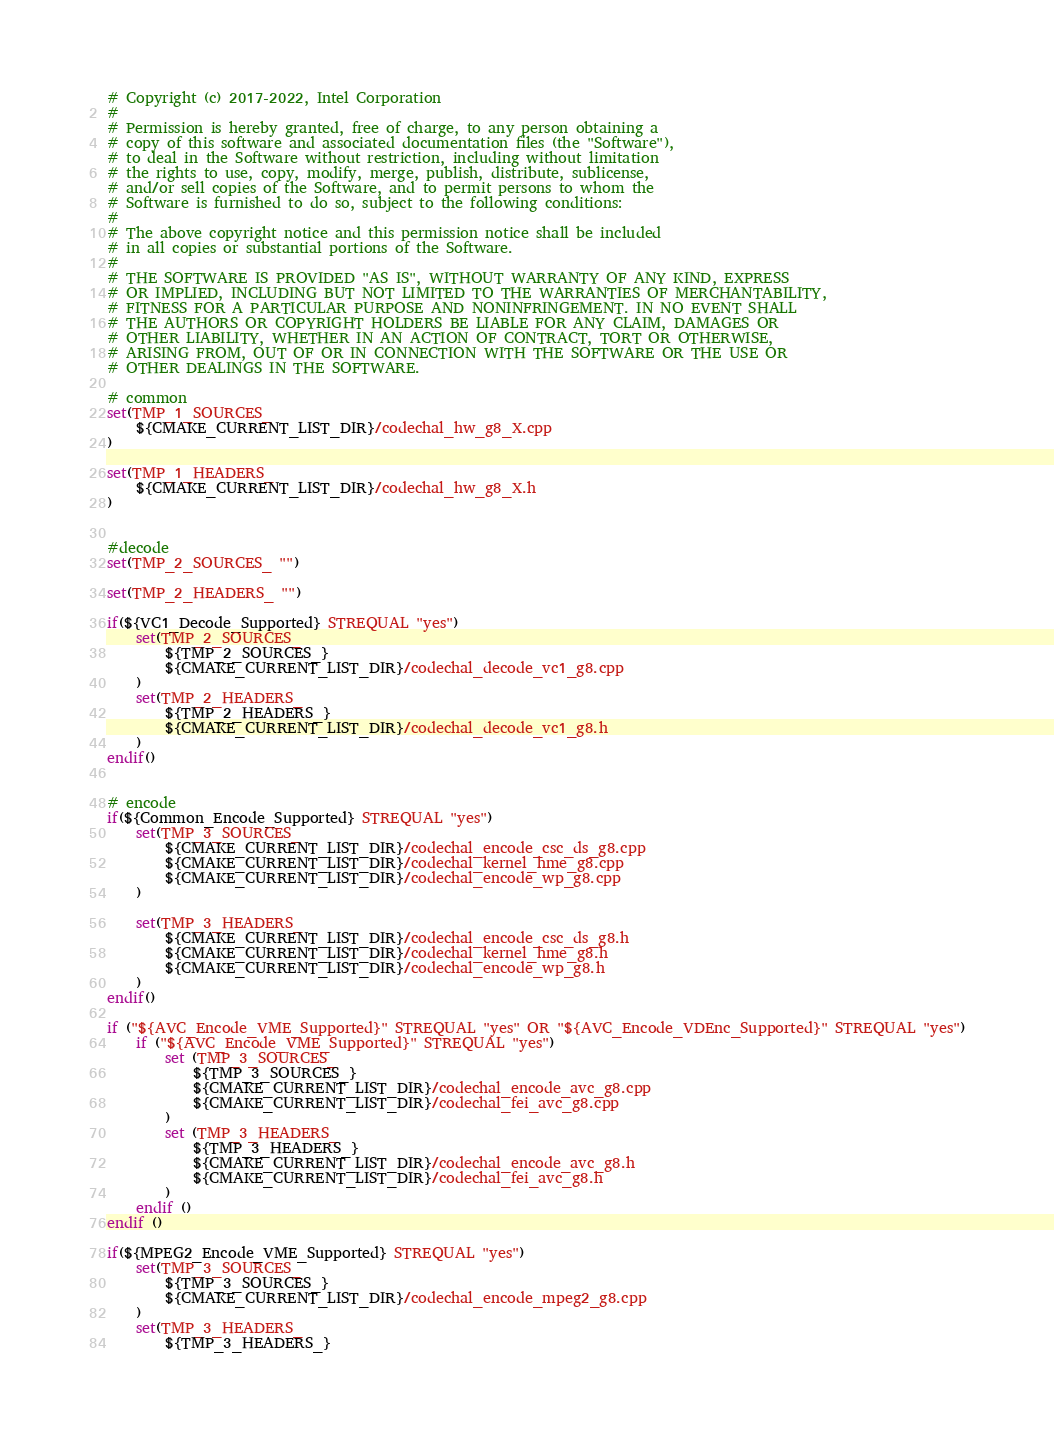Convert code to text. <code><loc_0><loc_0><loc_500><loc_500><_CMake_># Copyright (c) 2017-2022, Intel Corporation
#
# Permission is hereby granted, free of charge, to any person obtaining a
# copy of this software and associated documentation files (the "Software"),
# to deal in the Software without restriction, including without limitation
# the rights to use, copy, modify, merge, publish, distribute, sublicense,
# and/or sell copies of the Software, and to permit persons to whom the
# Software is furnished to do so, subject to the following conditions:
#
# The above copyright notice and this permission notice shall be included
# in all copies or substantial portions of the Software.
#
# THE SOFTWARE IS PROVIDED "AS IS", WITHOUT WARRANTY OF ANY KIND, EXPRESS
# OR IMPLIED, INCLUDING BUT NOT LIMITED TO THE WARRANTIES OF MERCHANTABILITY,
# FITNESS FOR A PARTICULAR PURPOSE AND NONINFRINGEMENT. IN NO EVENT SHALL
# THE AUTHORS OR COPYRIGHT HOLDERS BE LIABLE FOR ANY CLAIM, DAMAGES OR
# OTHER LIABILITY, WHETHER IN AN ACTION OF CONTRACT, TORT OR OTHERWISE,
# ARISING FROM, OUT OF OR IN CONNECTION WITH THE SOFTWARE OR THE USE OR
# OTHER DEALINGS IN THE SOFTWARE.

# common
set(TMP_1_SOURCES_
    ${CMAKE_CURRENT_LIST_DIR}/codechal_hw_g8_X.cpp
)

set(TMP_1_HEADERS_
    ${CMAKE_CURRENT_LIST_DIR}/codechal_hw_g8_X.h
)


#decode
set(TMP_2_SOURCES_ "")

set(TMP_2_HEADERS_ "")

if(${VC1_Decode_Supported} STREQUAL "yes")
    set(TMP_2_SOURCES_
        ${TMP_2_SOURCES_}
        ${CMAKE_CURRENT_LIST_DIR}/codechal_decode_vc1_g8.cpp
    )
    set(TMP_2_HEADERS_
        ${TMP_2_HEADERS_}
        ${CMAKE_CURRENT_LIST_DIR}/codechal_decode_vc1_g8.h
    )
endif()


# encode
if(${Common_Encode_Supported} STREQUAL "yes")
    set(TMP_3_SOURCES_
        ${CMAKE_CURRENT_LIST_DIR}/codechal_encode_csc_ds_g8.cpp
        ${CMAKE_CURRENT_LIST_DIR}/codechal_kernel_hme_g8.cpp
        ${CMAKE_CURRENT_LIST_DIR}/codechal_encode_wp_g8.cpp
    )

    set(TMP_3_HEADERS_
        ${CMAKE_CURRENT_LIST_DIR}/codechal_encode_csc_ds_g8.h
        ${CMAKE_CURRENT_LIST_DIR}/codechal_kernel_hme_g8.h
        ${CMAKE_CURRENT_LIST_DIR}/codechal_encode_wp_g8.h
    )
endif()

if ("${AVC_Encode_VME_Supported}" STREQUAL "yes" OR "${AVC_Encode_VDEnc_Supported}" STREQUAL "yes")
    if ("${AVC_Encode_VME_Supported}" STREQUAL "yes")
        set (TMP_3_SOURCES_
            ${TMP_3_SOURCES_}
            ${CMAKE_CURRENT_LIST_DIR}/codechal_encode_avc_g8.cpp
            ${CMAKE_CURRENT_LIST_DIR}/codechal_fei_avc_g8.cpp
        )
        set (TMP_3_HEADERS_
            ${TMP_3_HEADERS_}
            ${CMAKE_CURRENT_LIST_DIR}/codechal_encode_avc_g8.h
            ${CMAKE_CURRENT_LIST_DIR}/codechal_fei_avc_g8.h
        )
    endif ()
endif ()

if(${MPEG2_Encode_VME_Supported} STREQUAL "yes")
    set(TMP_3_SOURCES_
        ${TMP_3_SOURCES_}
        ${CMAKE_CURRENT_LIST_DIR}/codechal_encode_mpeg2_g8.cpp
    )
    set(TMP_3_HEADERS_
        ${TMP_3_HEADERS_}</code> 